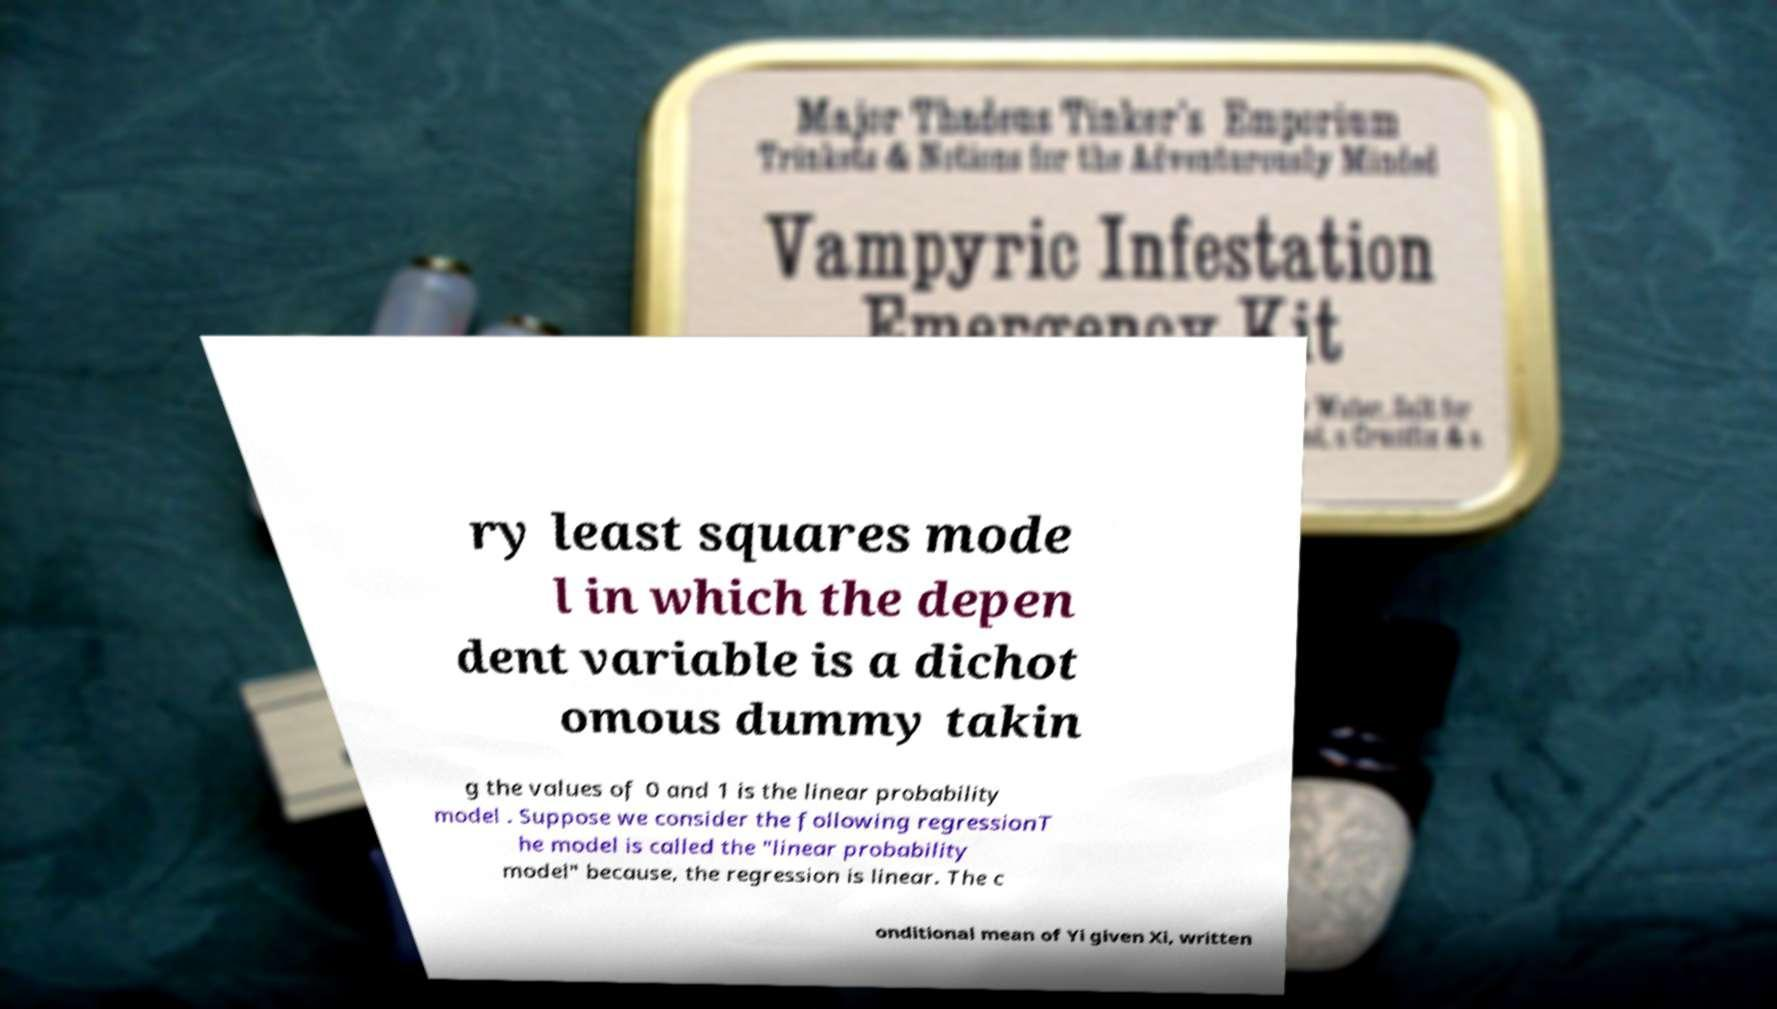Can you read and provide the text displayed in the image?This photo seems to have some interesting text. Can you extract and type it out for me? ry least squares mode l in which the depen dent variable is a dichot omous dummy takin g the values of 0 and 1 is the linear probability model . Suppose we consider the following regressionT he model is called the "linear probability model" because, the regression is linear. The c onditional mean of Yi given Xi, written 